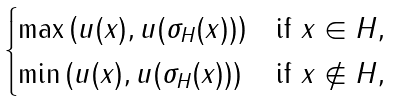Convert formula to latex. <formula><loc_0><loc_0><loc_500><loc_500>\begin{cases} \max \left ( u ( x ) , u ( \sigma _ { H } ( x ) ) \right ) & \text {if $x \in H$} , \\ \min \left ( u ( x ) , u ( \sigma _ { H } ( x ) ) \right ) & \text {if $x \not \in H$} , \end{cases}</formula> 